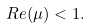Convert formula to latex. <formula><loc_0><loc_0><loc_500><loc_500>R e ( \mu ) < 1 .</formula> 